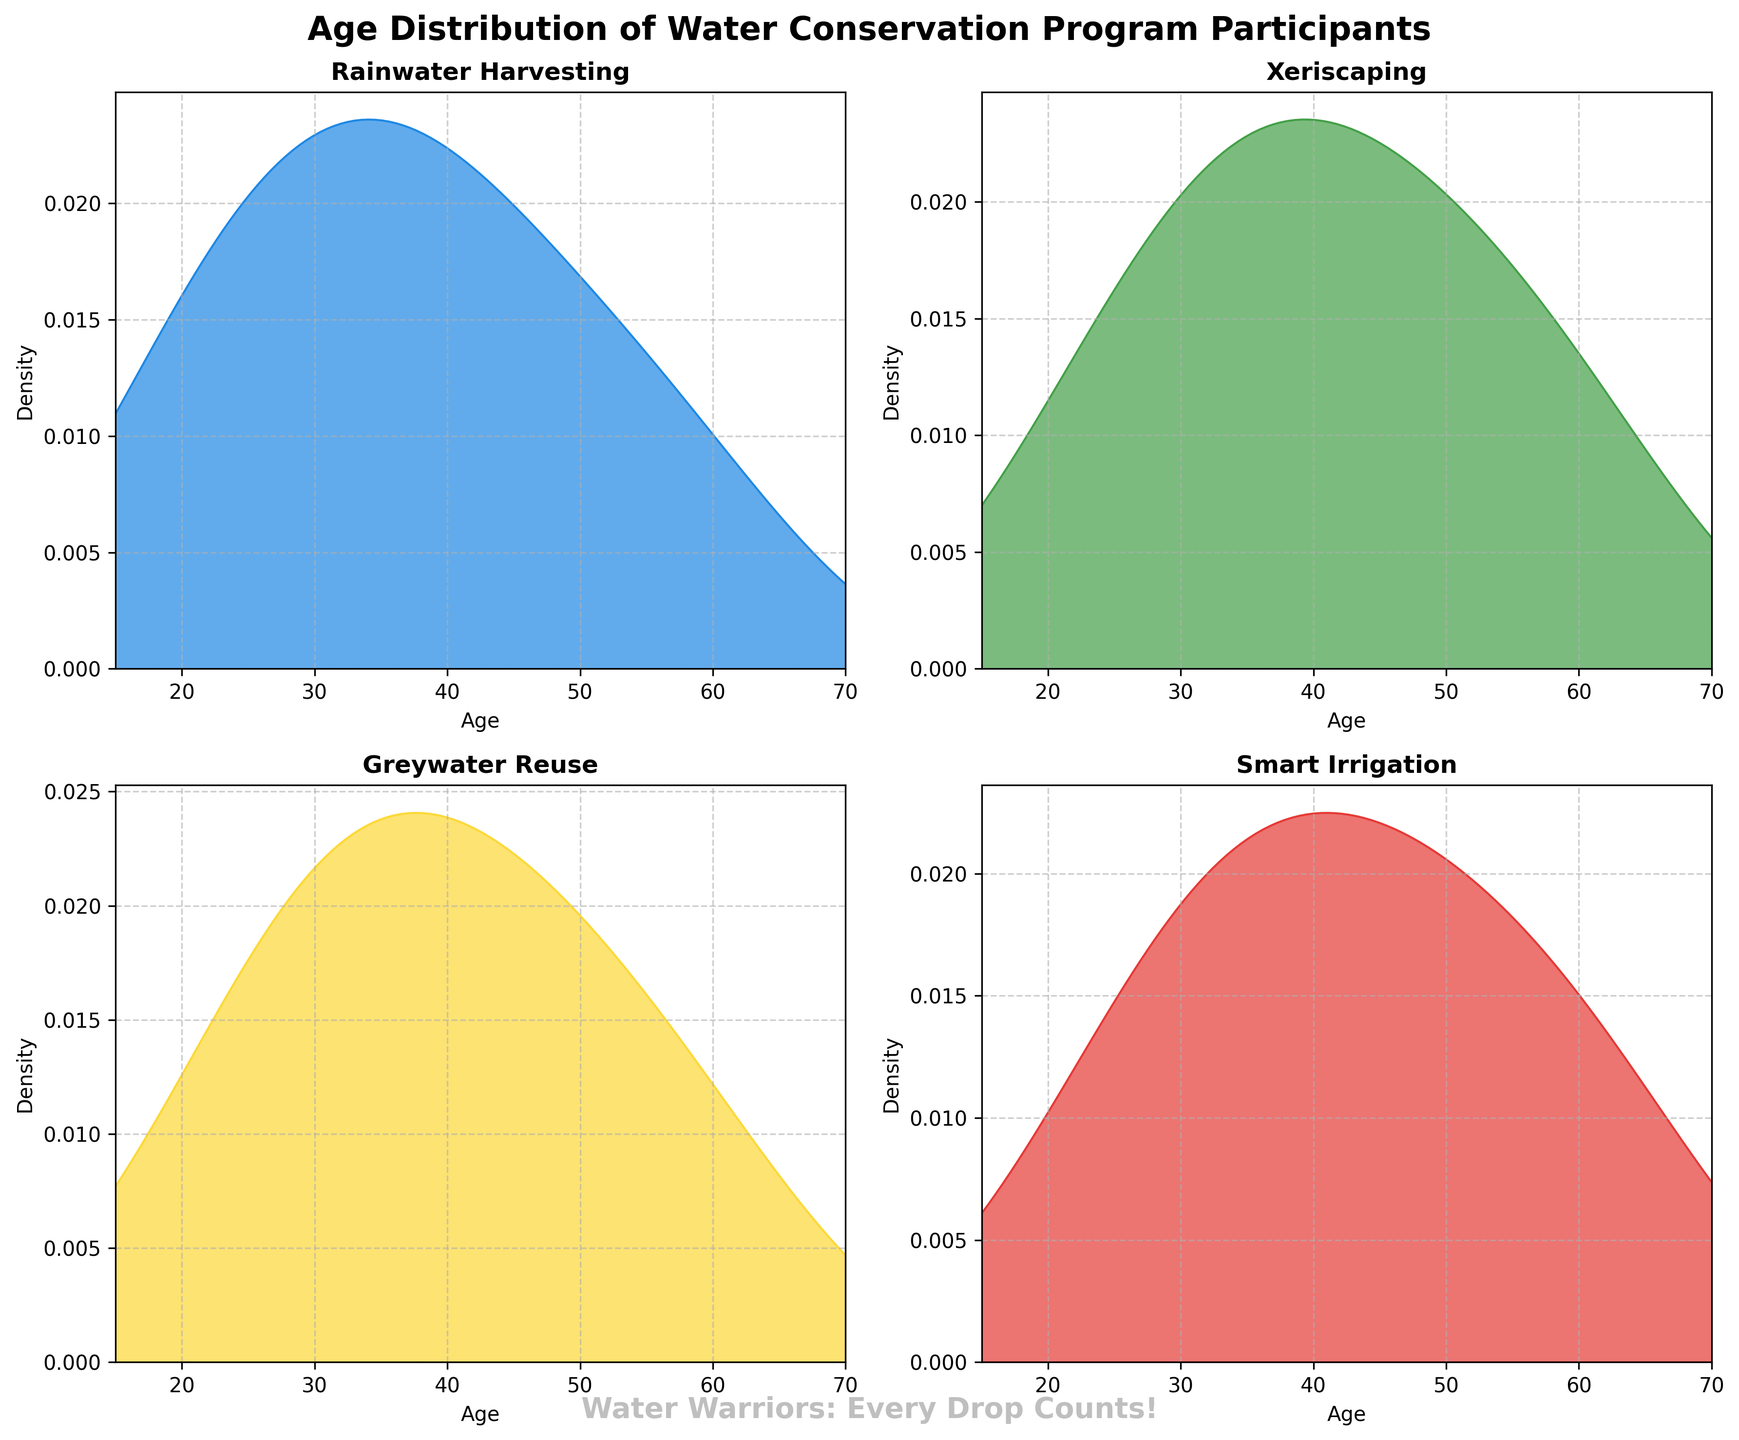Which program has the highest peak density value? The highest peak density, where the curve reaches its maximum height, appears in the plot for Smart Irrigation. This indicates a higher concentration of participants in certain age ranges.
Answer: Smart Irrigation What age range shows the highest density of participants in the Rainwater Harvesting program? The Rainwater Harvesting density plot shows the highest peak around the ages of 35-45, indicating the most participants in this age range.
Answer: 35-45 Is the peak density value of the Greywater Reuse program higher than that of the Xeriscaping program? By comparing the peak heights of the density curves, we can see that the peak of the Greywater Reuse curve is slightly lower than the peak of the Xeriscaping curve.
Answer: No Which program has the widest spread in the age of participants? The spread (width) of a density plot indicates the range of ages participating. Rainwater Harvesting and Greywater Reuse have similar spreads, but Rainwater Harvesting's range is slightly broader.
Answer: Rainwater Harvesting What is a common age trend among all the programs? All density plots show noticeable peaks around ages 35-45, indicating that people in this age range are more active in water conservation programs.
Answer: 35-45 Are there more participants in Rainwater Harvesting or Xeriscaping around age 30? The density plot of Rainwater Harvesting is higher than that of Xeriscaping around age 30, indicating more participants.
Answer: Rainwater Harvesting Which program has the least number of participants over the age of 60? The plot for Xeriscaping shows the lowest density over the age of 60 compared to the other programs.
Answer: Xeriscaping How does the peak for Smart Irrigation compare to the peak for Greywater Reuse? The peak for Smart Irrigation is higher than the peak for Greywater Reuse, indicating a higher concentration of participants at its highest density point.
Answer: Smart Irrigation What is the age range for the maximum density of participants in Smart Irrigation? The Smart Irrigation plot peaks around the ages of 40-50, showing the highest density of participants in this age range.
Answer: 40-50 Which two programs have the most similar density distributions? By inspecting the density curves, Rainwater Harvesting and Greywater Reuse have quite similar distributions, particularly in their peaks and overall spread around ages 30-50.
Answer: Rainwater Harvesting and Greywater Reuse 